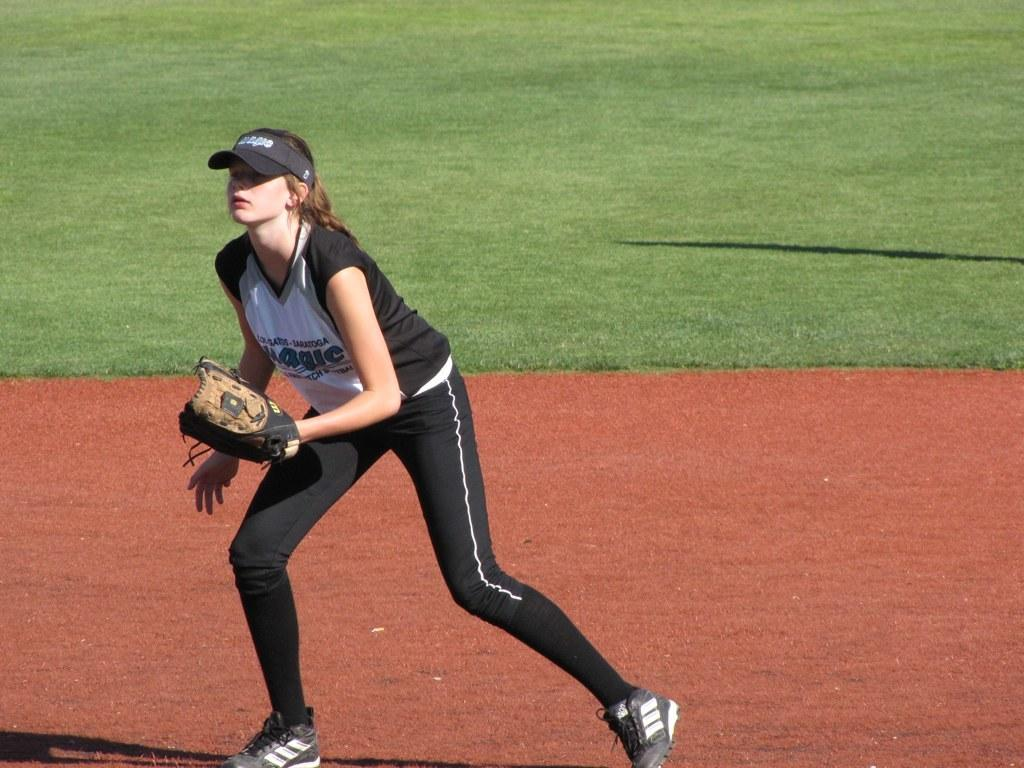Who is present in the image? There is a woman in the image. What is the woman's position in the image? The woman is on the ground. What accessories is the woman wearing? The woman is wearing a glove and a cap. What type of environment is visible in the background of the image? There is grass visible in the background of the image. What type of music can be heard in the background of the image? There is no music present in the image; it is a still photograph. What effect does the glove have on the woman's ability to perform a task in the image? The image does not show the woman performing any tasks, so it is impossible to determine the effect of the glove on her ability to do so. 